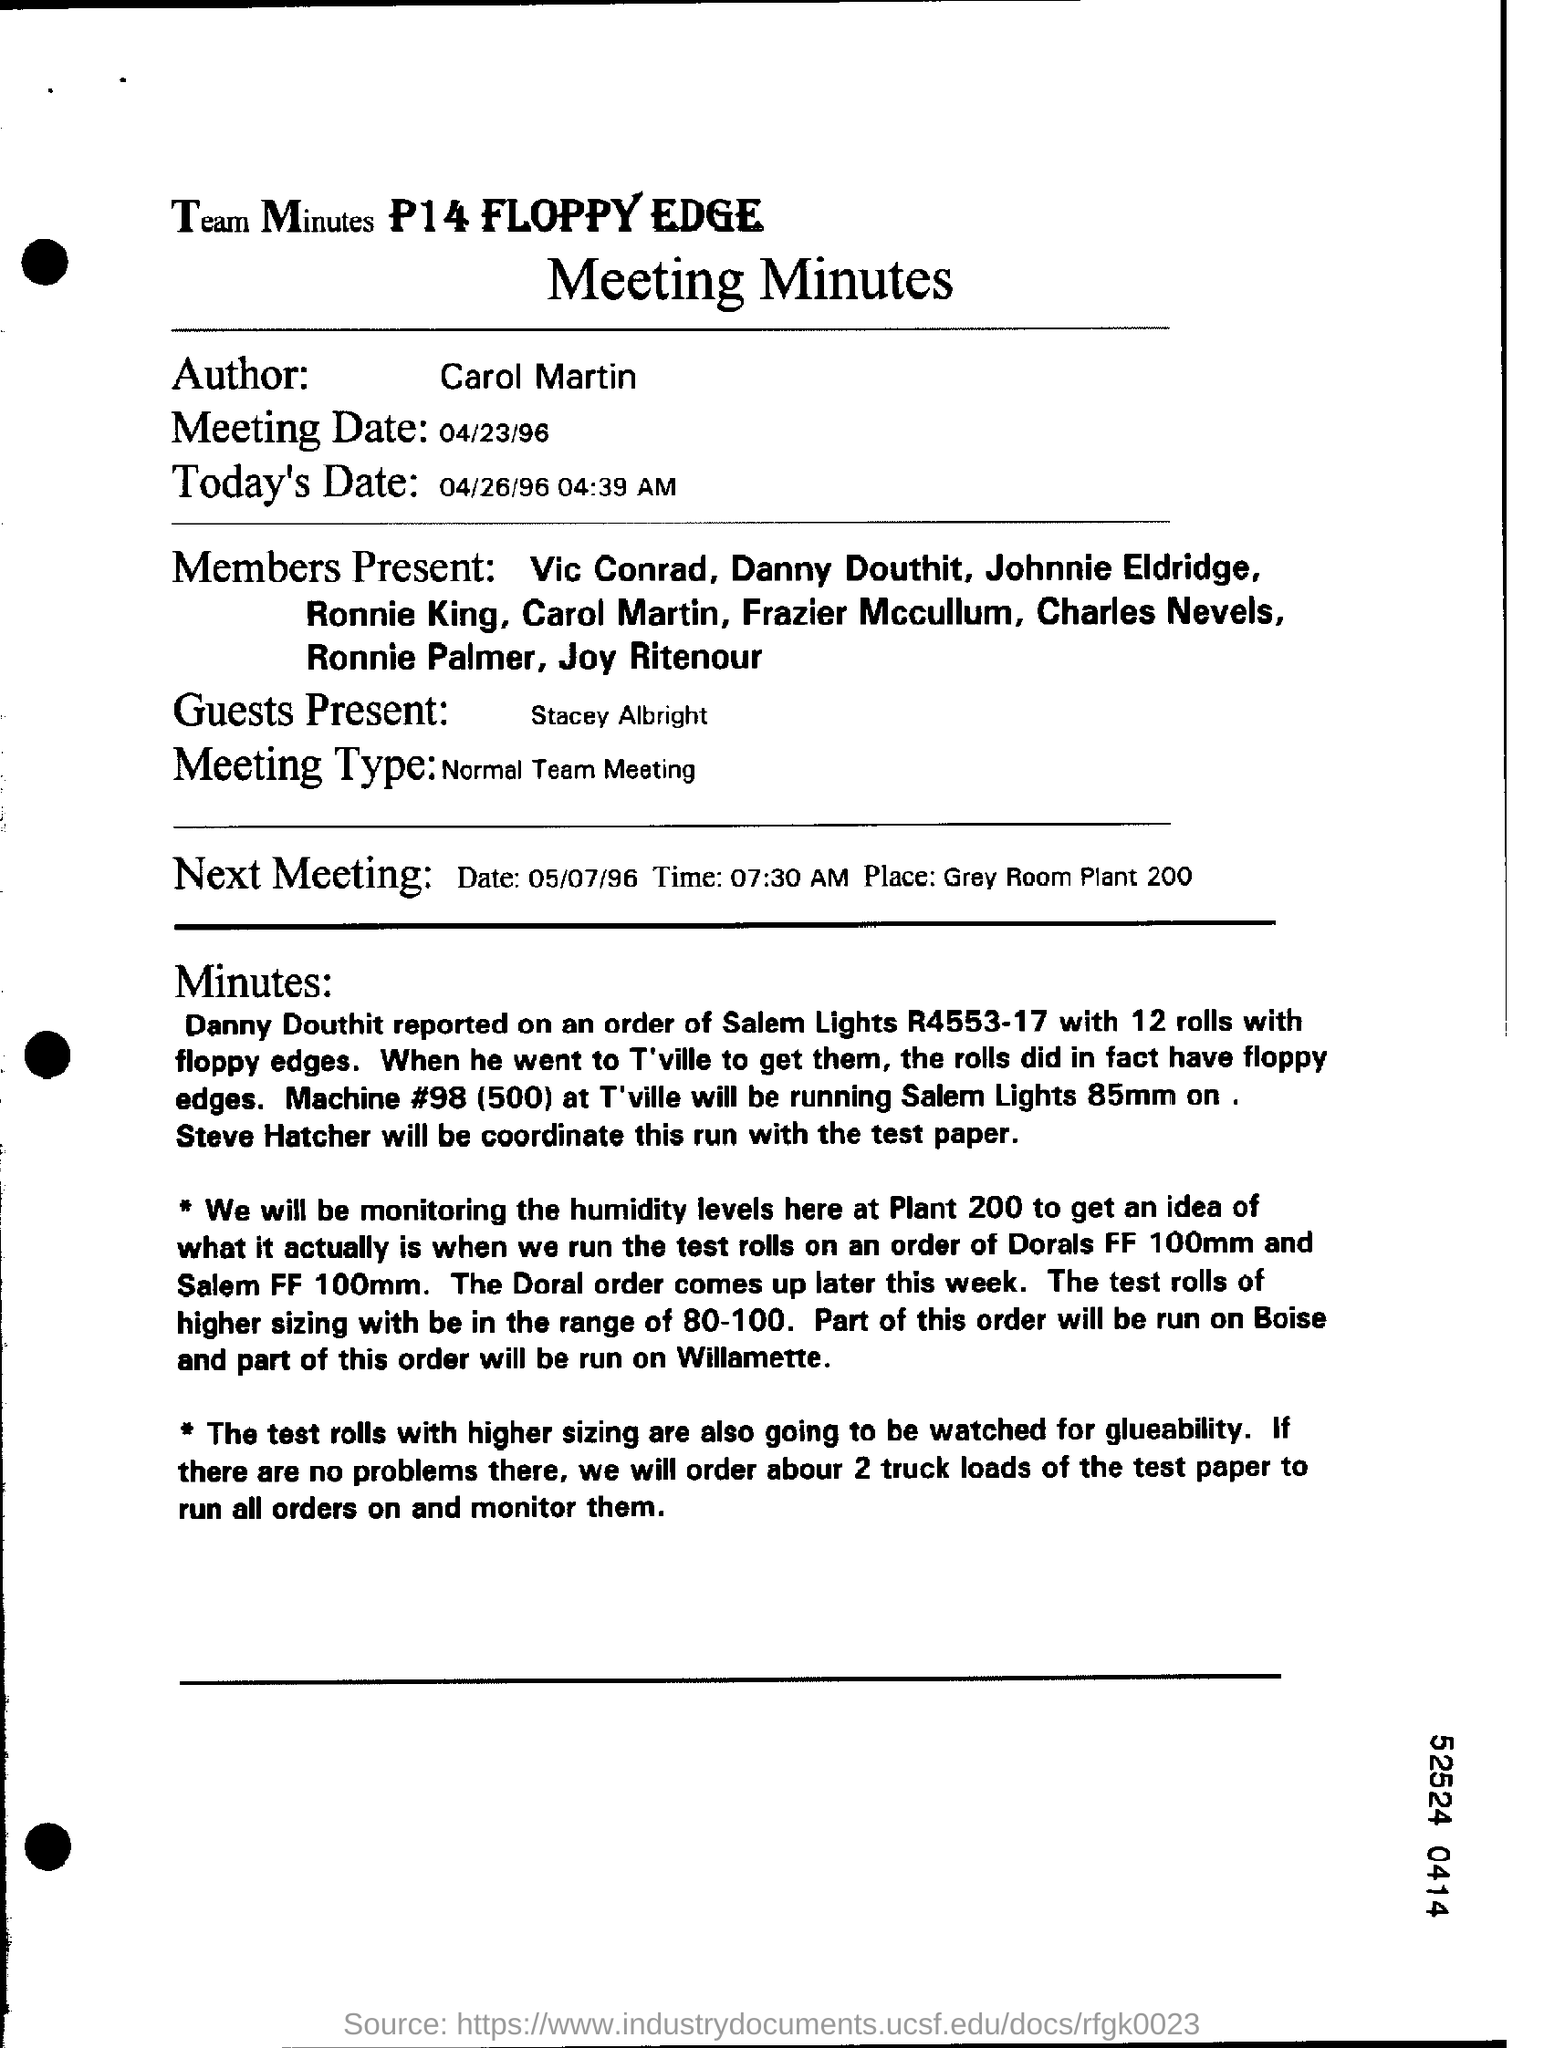Identify some key points in this picture. The current date in the document is April 26, 1996 at 04:39 am. The guests present in the document are Stacey Albright. The meeting type is a normal team meeting. The meeting date mentioned in the document is 04/23/96. The name of the author is Carol Martin. 